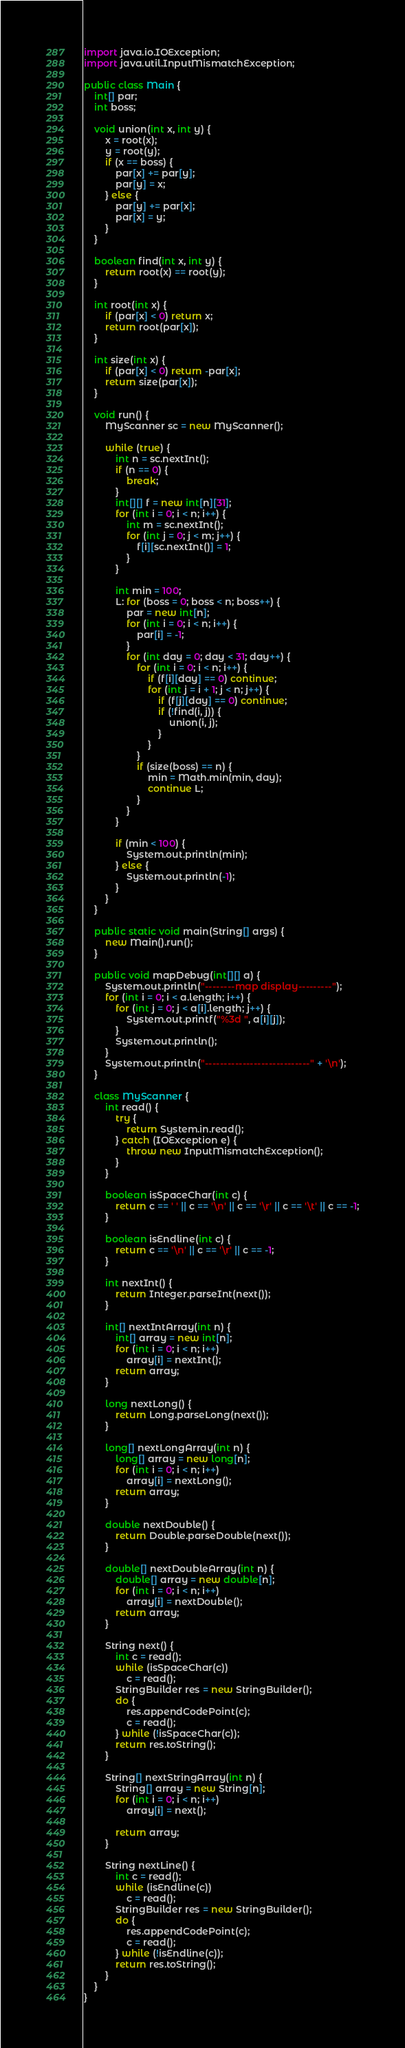Convert code to text. <code><loc_0><loc_0><loc_500><loc_500><_Java_>import java.io.IOException;
import java.util.InputMismatchException;

public class Main {
	int[] par;
	int boss;

	void union(int x, int y) {
		x = root(x);
		y = root(y);
		if (x == boss) {
			par[x] += par[y];
			par[y] = x;
		} else {
			par[y] += par[x];
			par[x] = y;
		}
	}

	boolean find(int x, int y) {
		return root(x) == root(y);
	}

	int root(int x) {
		if (par[x] < 0) return x;
		return root(par[x]);
	}

	int size(int x) {
		if (par[x] < 0) return -par[x];
		return size(par[x]);
	}

	void run() {
		MyScanner sc = new MyScanner();

		while (true) {
			int n = sc.nextInt();
			if (n == 0) {
				break;
			}
			int[][] f = new int[n][31];
			for (int i = 0; i < n; i++) {
				int m = sc.nextInt();
				for (int j = 0; j < m; j++) {
					f[i][sc.nextInt()] = 1;
				}
			}

			int min = 100;
			L: for (boss = 0; boss < n; boss++) {
				par = new int[n];
				for (int i = 0; i < n; i++) {
					par[i] = -1;
				}
				for (int day = 0; day < 31; day++) {
					for (int i = 0; i < n; i++) {
						if (f[i][day] == 0) continue;
						for (int j = i + 1; j < n; j++) {
							if (f[j][day] == 0) continue;
							if (!find(i, j)) {
								union(i, j);
							}
						}
					}
					if (size(boss) == n) {
						min = Math.min(min, day);
						continue L;
					}
				}
			}

			if (min < 100) {
				System.out.println(min);
			} else {
				System.out.println(-1);
			}
		}
	}

	public static void main(String[] args) {
		new Main().run();
	}

	public void mapDebug(int[][] a) {
		System.out.println("--------map display---------");
		for (int i = 0; i < a.length; i++) {
			for (int j = 0; j < a[i].length; j++) {
				System.out.printf("%3d ", a[i][j]);
			}
			System.out.println();
		}
		System.out.println("----------------------------" + '\n');
	}

	class MyScanner {
		int read() {
			try {
				return System.in.read();
			} catch (IOException e) {
				throw new InputMismatchException();
			}
		}

		boolean isSpaceChar(int c) {
			return c == ' ' || c == '\n' || c == '\r' || c == '\t' || c == -1;
		}

		boolean isEndline(int c) {
			return c == '\n' || c == '\r' || c == -1;
		}

		int nextInt() {
			return Integer.parseInt(next());
		}

		int[] nextIntArray(int n) {
			int[] array = new int[n];
			for (int i = 0; i < n; i++)
				array[i] = nextInt();
			return array;
		}

		long nextLong() {
			return Long.parseLong(next());
		}

		long[] nextLongArray(int n) {
			long[] array = new long[n];
			for (int i = 0; i < n; i++)
				array[i] = nextLong();
			return array;
		}

		double nextDouble() {
			return Double.parseDouble(next());
		}

		double[] nextDoubleArray(int n) {
			double[] array = new double[n];
			for (int i = 0; i < n; i++)
				array[i] = nextDouble();
			return array;
		}

		String next() {
			int c = read();
			while (isSpaceChar(c))
				c = read();
			StringBuilder res = new StringBuilder();
			do {
				res.appendCodePoint(c);
				c = read();
			} while (!isSpaceChar(c));
			return res.toString();
		}

		String[] nextStringArray(int n) {
			String[] array = new String[n];
			for (int i = 0; i < n; i++)
				array[i] = next();

			return array;
		}

		String nextLine() {
			int c = read();
			while (isEndline(c))
				c = read();
			StringBuilder res = new StringBuilder();
			do {
				res.appendCodePoint(c);
				c = read();
			} while (!isEndline(c));
			return res.toString();
		}
	}
}</code> 